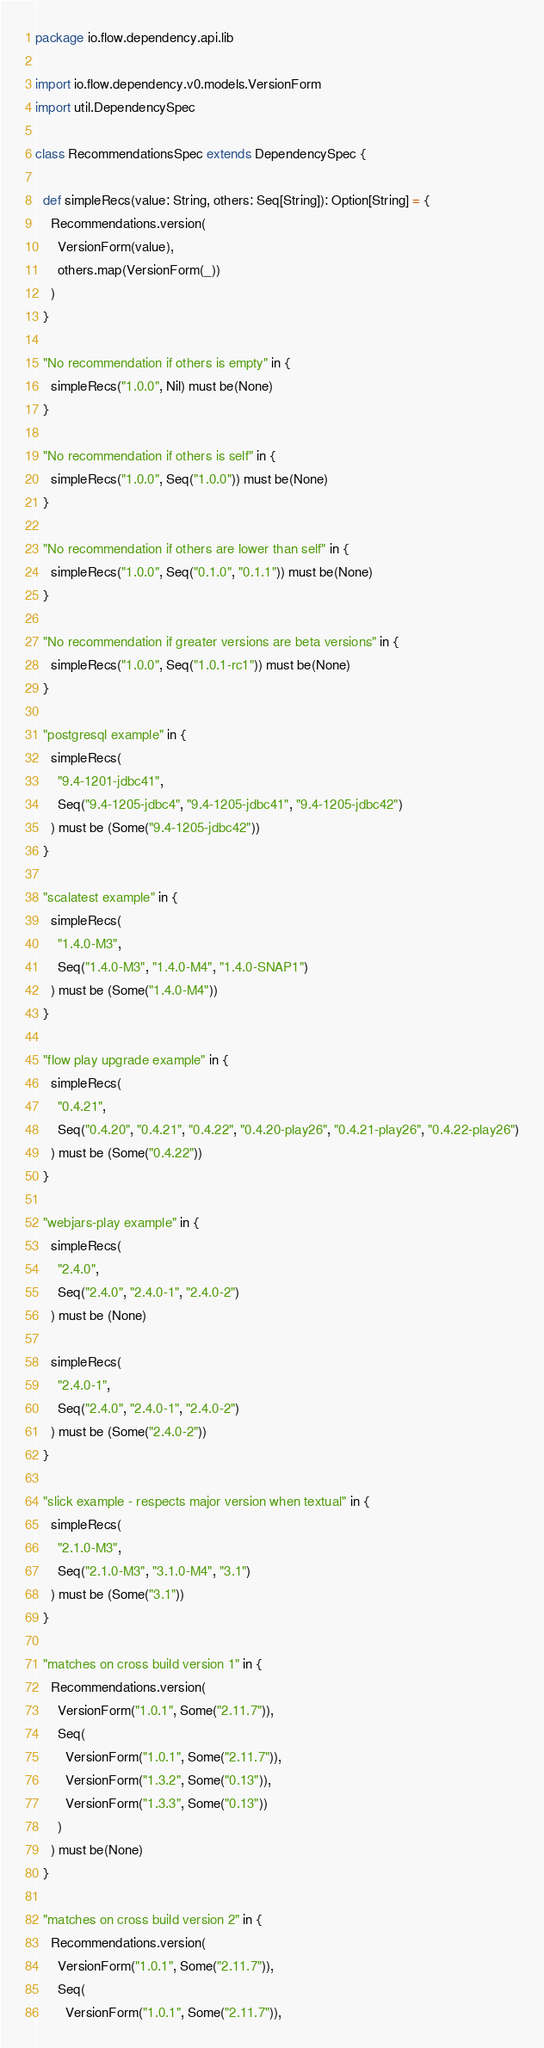<code> <loc_0><loc_0><loc_500><loc_500><_Scala_>package io.flow.dependency.api.lib

import io.flow.dependency.v0.models.VersionForm
import util.DependencySpec

class RecommendationsSpec extends DependencySpec {

  def simpleRecs(value: String, others: Seq[String]): Option[String] = {
    Recommendations.version(
      VersionForm(value),
      others.map(VersionForm(_))
    )
  }

  "No recommendation if others is empty" in {
    simpleRecs("1.0.0", Nil) must be(None)
  }

  "No recommendation if others is self" in {
    simpleRecs("1.0.0", Seq("1.0.0")) must be(None)
  }

  "No recommendation if others are lower than self" in {
    simpleRecs("1.0.0", Seq("0.1.0", "0.1.1")) must be(None)
  }

  "No recommendation if greater versions are beta versions" in {
    simpleRecs("1.0.0", Seq("1.0.1-rc1")) must be(None)
  }

  "postgresql example" in {
    simpleRecs(
      "9.4-1201-jdbc41",
      Seq("9.4-1205-jdbc4", "9.4-1205-jdbc41", "9.4-1205-jdbc42")
    ) must be (Some("9.4-1205-jdbc42"))
  }

  "scalatest example" in {
    simpleRecs(
      "1.4.0-M3",
      Seq("1.4.0-M3", "1.4.0-M4", "1.4.0-SNAP1")
    ) must be (Some("1.4.0-M4"))
  }

  "flow play upgrade example" in {
    simpleRecs(
      "0.4.21",
      Seq("0.4.20", "0.4.21", "0.4.22", "0.4.20-play26", "0.4.21-play26", "0.4.22-play26")
    ) must be (Some("0.4.22"))
  }

  "webjars-play example" in {
    simpleRecs(
      "2.4.0",
      Seq("2.4.0", "2.4.0-1", "2.4.0-2")
    ) must be (None)

    simpleRecs(
      "2.4.0-1",
      Seq("2.4.0", "2.4.0-1", "2.4.0-2")
    ) must be (Some("2.4.0-2"))
  }

  "slick example - respects major version when textual" in {
    simpleRecs(
      "2.1.0-M3",
      Seq("2.1.0-M3", "3.1.0-M4", "3.1")
    ) must be (Some("3.1"))
  }

  "matches on cross build version 1" in {
    Recommendations.version(
      VersionForm("1.0.1", Some("2.11.7")),
      Seq(
        VersionForm("1.0.1", Some("2.11.7")),
        VersionForm("1.3.2", Some("0.13")),
        VersionForm("1.3.3", Some("0.13"))
      )
    ) must be(None)
  }

  "matches on cross build version 2" in {
    Recommendations.version(
      VersionForm("1.0.1", Some("2.11.7")),
      Seq(
        VersionForm("1.0.1", Some("2.11.7")),</code> 